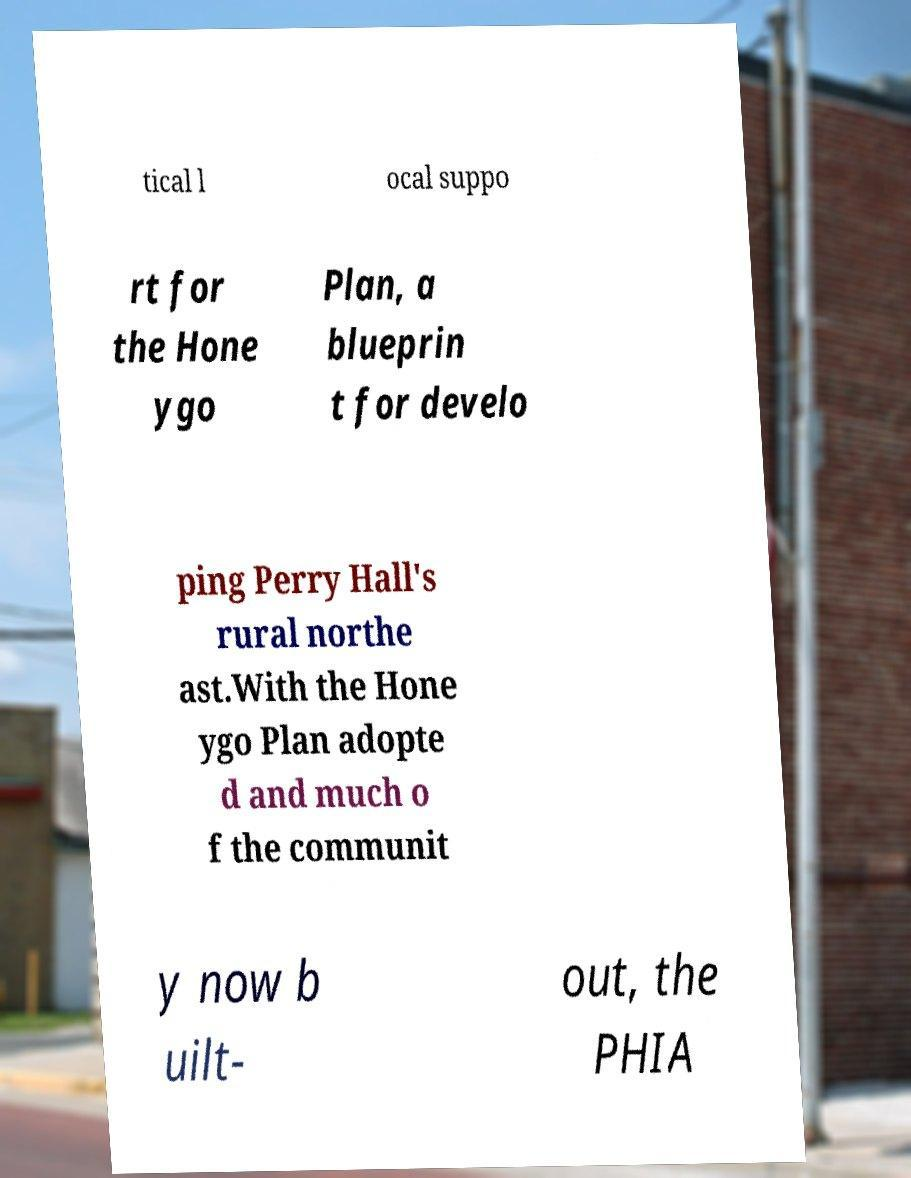Please identify and transcribe the text found in this image. tical l ocal suppo rt for the Hone ygo Plan, a blueprin t for develo ping Perry Hall's rural northe ast.With the Hone ygo Plan adopte d and much o f the communit y now b uilt- out, the PHIA 